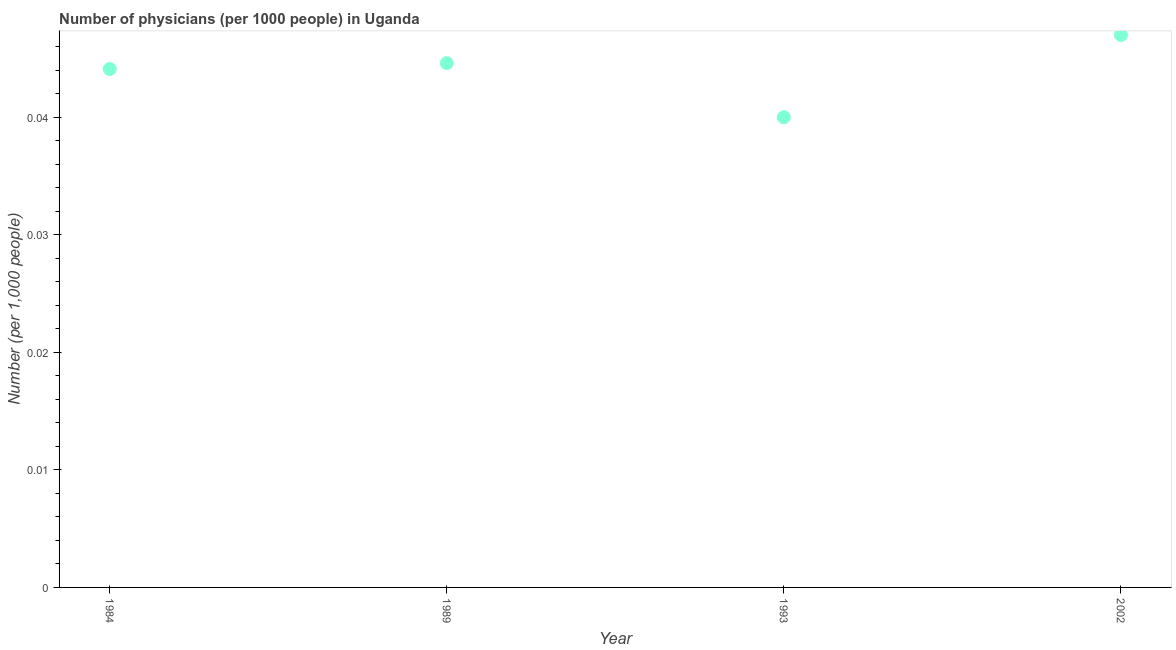What is the number of physicians in 1984?
Ensure brevity in your answer.  0.04. Across all years, what is the maximum number of physicians?
Your response must be concise. 0.05. Across all years, what is the minimum number of physicians?
Give a very brief answer. 0.04. In which year was the number of physicians maximum?
Your answer should be very brief. 2002. In which year was the number of physicians minimum?
Make the answer very short. 1993. What is the sum of the number of physicians?
Provide a succinct answer. 0.18. What is the difference between the number of physicians in 1984 and 2002?
Provide a succinct answer. -0. What is the average number of physicians per year?
Provide a short and direct response. 0.04. What is the median number of physicians?
Ensure brevity in your answer.  0.04. Do a majority of the years between 1989 and 2002 (inclusive) have number of physicians greater than 0.026000000000000002 ?
Your answer should be very brief. Yes. What is the ratio of the number of physicians in 1984 to that in 1989?
Offer a very short reply. 0.99. What is the difference between the highest and the second highest number of physicians?
Your answer should be compact. 0. Is the sum of the number of physicians in 1984 and 1993 greater than the maximum number of physicians across all years?
Provide a succinct answer. Yes. What is the difference between the highest and the lowest number of physicians?
Provide a short and direct response. 0.01. How many dotlines are there?
Ensure brevity in your answer.  1. Does the graph contain any zero values?
Your answer should be compact. No. Does the graph contain grids?
Offer a very short reply. No. What is the title of the graph?
Your answer should be compact. Number of physicians (per 1000 people) in Uganda. What is the label or title of the X-axis?
Your answer should be very brief. Year. What is the label or title of the Y-axis?
Provide a succinct answer. Number (per 1,0 people). What is the Number (per 1,000 people) in 1984?
Provide a short and direct response. 0.04. What is the Number (per 1,000 people) in 1989?
Offer a terse response. 0.04. What is the Number (per 1,000 people) in 1993?
Your answer should be compact. 0.04. What is the Number (per 1,000 people) in 2002?
Ensure brevity in your answer.  0.05. What is the difference between the Number (per 1,000 people) in 1984 and 1989?
Provide a succinct answer. -0. What is the difference between the Number (per 1,000 people) in 1984 and 1993?
Make the answer very short. 0. What is the difference between the Number (per 1,000 people) in 1984 and 2002?
Provide a short and direct response. -0. What is the difference between the Number (per 1,000 people) in 1989 and 1993?
Ensure brevity in your answer.  0. What is the difference between the Number (per 1,000 people) in 1989 and 2002?
Offer a terse response. -0. What is the difference between the Number (per 1,000 people) in 1993 and 2002?
Your response must be concise. -0.01. What is the ratio of the Number (per 1,000 people) in 1984 to that in 1989?
Your answer should be compact. 0.99. What is the ratio of the Number (per 1,000 people) in 1984 to that in 1993?
Keep it short and to the point. 1.1. What is the ratio of the Number (per 1,000 people) in 1984 to that in 2002?
Ensure brevity in your answer.  0.94. What is the ratio of the Number (per 1,000 people) in 1989 to that in 1993?
Your answer should be very brief. 1.11. What is the ratio of the Number (per 1,000 people) in 1989 to that in 2002?
Make the answer very short. 0.95. What is the ratio of the Number (per 1,000 people) in 1993 to that in 2002?
Provide a succinct answer. 0.85. 